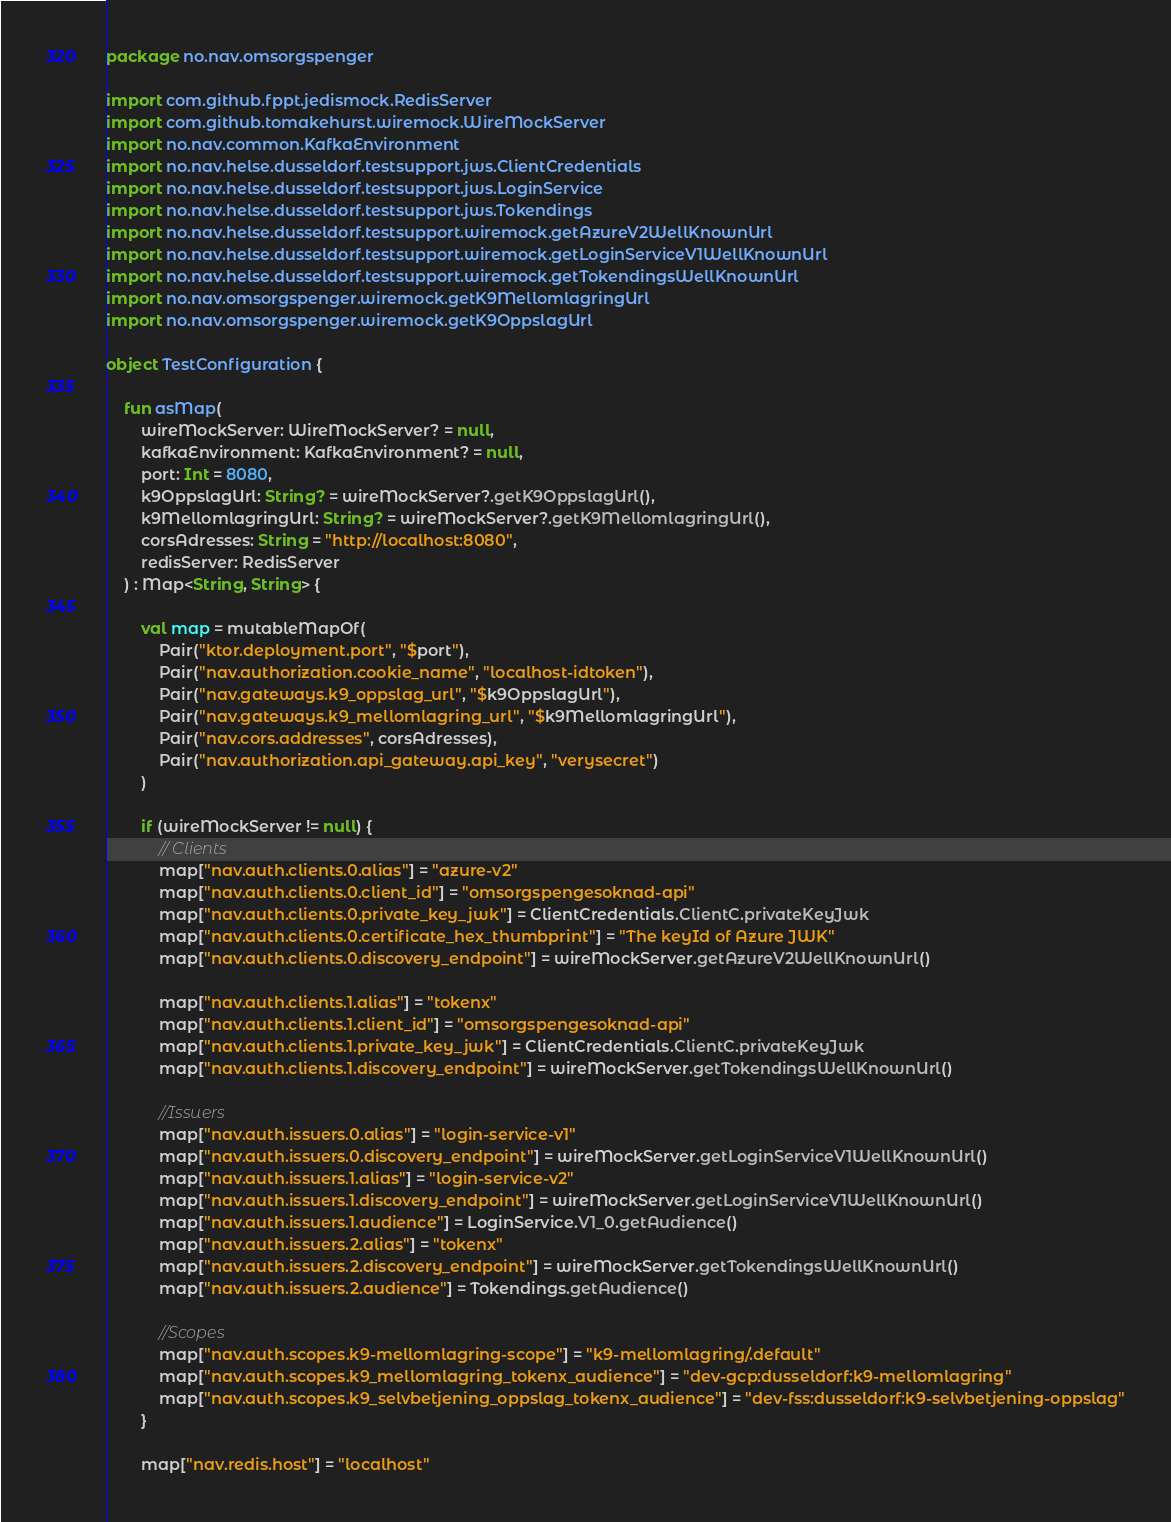Convert code to text. <code><loc_0><loc_0><loc_500><loc_500><_Kotlin_>package no.nav.omsorgspenger

import com.github.fppt.jedismock.RedisServer
import com.github.tomakehurst.wiremock.WireMockServer
import no.nav.common.KafkaEnvironment
import no.nav.helse.dusseldorf.testsupport.jws.ClientCredentials
import no.nav.helse.dusseldorf.testsupport.jws.LoginService
import no.nav.helse.dusseldorf.testsupport.jws.Tokendings
import no.nav.helse.dusseldorf.testsupport.wiremock.getAzureV2WellKnownUrl
import no.nav.helse.dusseldorf.testsupport.wiremock.getLoginServiceV1WellKnownUrl
import no.nav.helse.dusseldorf.testsupport.wiremock.getTokendingsWellKnownUrl
import no.nav.omsorgspenger.wiremock.getK9MellomlagringUrl
import no.nav.omsorgspenger.wiremock.getK9OppslagUrl

object TestConfiguration {

    fun asMap(
        wireMockServer: WireMockServer? = null,
        kafkaEnvironment: KafkaEnvironment? = null,
        port: Int = 8080,
        k9OppslagUrl: String? = wireMockServer?.getK9OppslagUrl(),
        k9MellomlagringUrl: String? = wireMockServer?.getK9MellomlagringUrl(),
        corsAdresses: String = "http://localhost:8080",
        redisServer: RedisServer
    ) : Map<String, String> {

        val map = mutableMapOf(
            Pair("ktor.deployment.port", "$port"),
            Pair("nav.authorization.cookie_name", "localhost-idtoken"),
            Pair("nav.gateways.k9_oppslag_url", "$k9OppslagUrl"),
            Pair("nav.gateways.k9_mellomlagring_url", "$k9MellomlagringUrl"),
            Pair("nav.cors.addresses", corsAdresses),
            Pair("nav.authorization.api_gateway.api_key", "verysecret")
        )

        if (wireMockServer != null) {
            // Clients
            map["nav.auth.clients.0.alias"] = "azure-v2"
            map["nav.auth.clients.0.client_id"] = "omsorgspengesoknad-api"
            map["nav.auth.clients.0.private_key_jwk"] = ClientCredentials.ClientC.privateKeyJwk
            map["nav.auth.clients.0.certificate_hex_thumbprint"] = "The keyId of Azure JWK"
            map["nav.auth.clients.0.discovery_endpoint"] = wireMockServer.getAzureV2WellKnownUrl()

            map["nav.auth.clients.1.alias"] = "tokenx"
            map["nav.auth.clients.1.client_id"] = "omsorgspengesoknad-api"
            map["nav.auth.clients.1.private_key_jwk"] = ClientCredentials.ClientC.privateKeyJwk
            map["nav.auth.clients.1.discovery_endpoint"] = wireMockServer.getTokendingsWellKnownUrl()

            //Issuers
            map["nav.auth.issuers.0.alias"] = "login-service-v1"
            map["nav.auth.issuers.0.discovery_endpoint"] = wireMockServer.getLoginServiceV1WellKnownUrl()
            map["nav.auth.issuers.1.alias"] = "login-service-v2"
            map["nav.auth.issuers.1.discovery_endpoint"] = wireMockServer.getLoginServiceV1WellKnownUrl()
            map["nav.auth.issuers.1.audience"] = LoginService.V1_0.getAudience()
            map["nav.auth.issuers.2.alias"] = "tokenx"
            map["nav.auth.issuers.2.discovery_endpoint"] = wireMockServer.getTokendingsWellKnownUrl()
            map["nav.auth.issuers.2.audience"] = Tokendings.getAudience()

            //Scopes
            map["nav.auth.scopes.k9-mellomlagring-scope"] = "k9-mellomlagring/.default"
            map["nav.auth.scopes.k9_mellomlagring_tokenx_audience"] = "dev-gcp:dusseldorf:k9-mellomlagring"
            map["nav.auth.scopes.k9_selvbetjening_oppslag_tokenx_audience"] = "dev-fss:dusseldorf:k9-selvbetjening-oppslag"
        }

        map["nav.redis.host"] = "localhost"</code> 